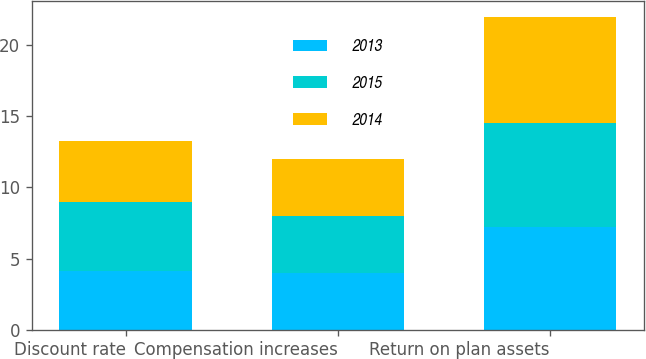Convert chart to OTSL. <chart><loc_0><loc_0><loc_500><loc_500><stacked_bar_chart><ecel><fcel>Discount rate<fcel>Compensation increases<fcel>Return on plan assets<nl><fcel>2013<fcel>4.15<fcel>4<fcel>7.25<nl><fcel>2015<fcel>4.85<fcel>4<fcel>7.25<nl><fcel>2014<fcel>4.25<fcel>4<fcel>7.5<nl></chart> 